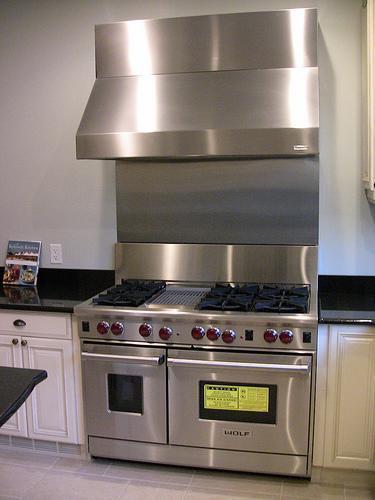How many oven doors are there?
Give a very brief answer. 2. 